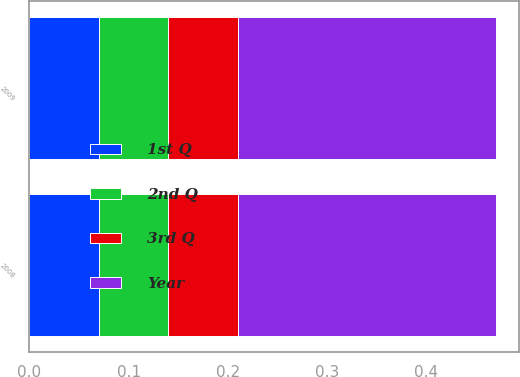Convert chart to OTSL. <chart><loc_0><loc_0><loc_500><loc_500><stacked_bar_chart><ecel><fcel>2009<fcel>2008<nl><fcel>Year<fcel>0.26<fcel>0.26<nl><fcel>2nd Q<fcel>0.07<fcel>0.07<nl><fcel>1st Q<fcel>0.07<fcel>0.07<nl><fcel>3rd Q<fcel>0.07<fcel>0.07<nl></chart> 